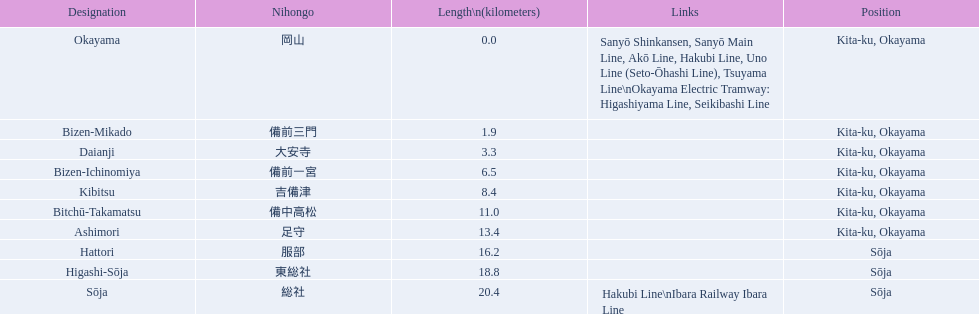What are all of the train names? Okayama, Bizen-Mikado, Daianji, Bizen-Ichinomiya, Kibitsu, Bitchū-Takamatsu, Ashimori, Hattori, Higashi-Sōja, Sōja. What is the distance for each? 0.0, 1.9, 3.3, 6.5, 8.4, 11.0, 13.4, 16.2, 18.8, 20.4. And which train's distance is between 1 and 2 km? Bizen-Mikado. 